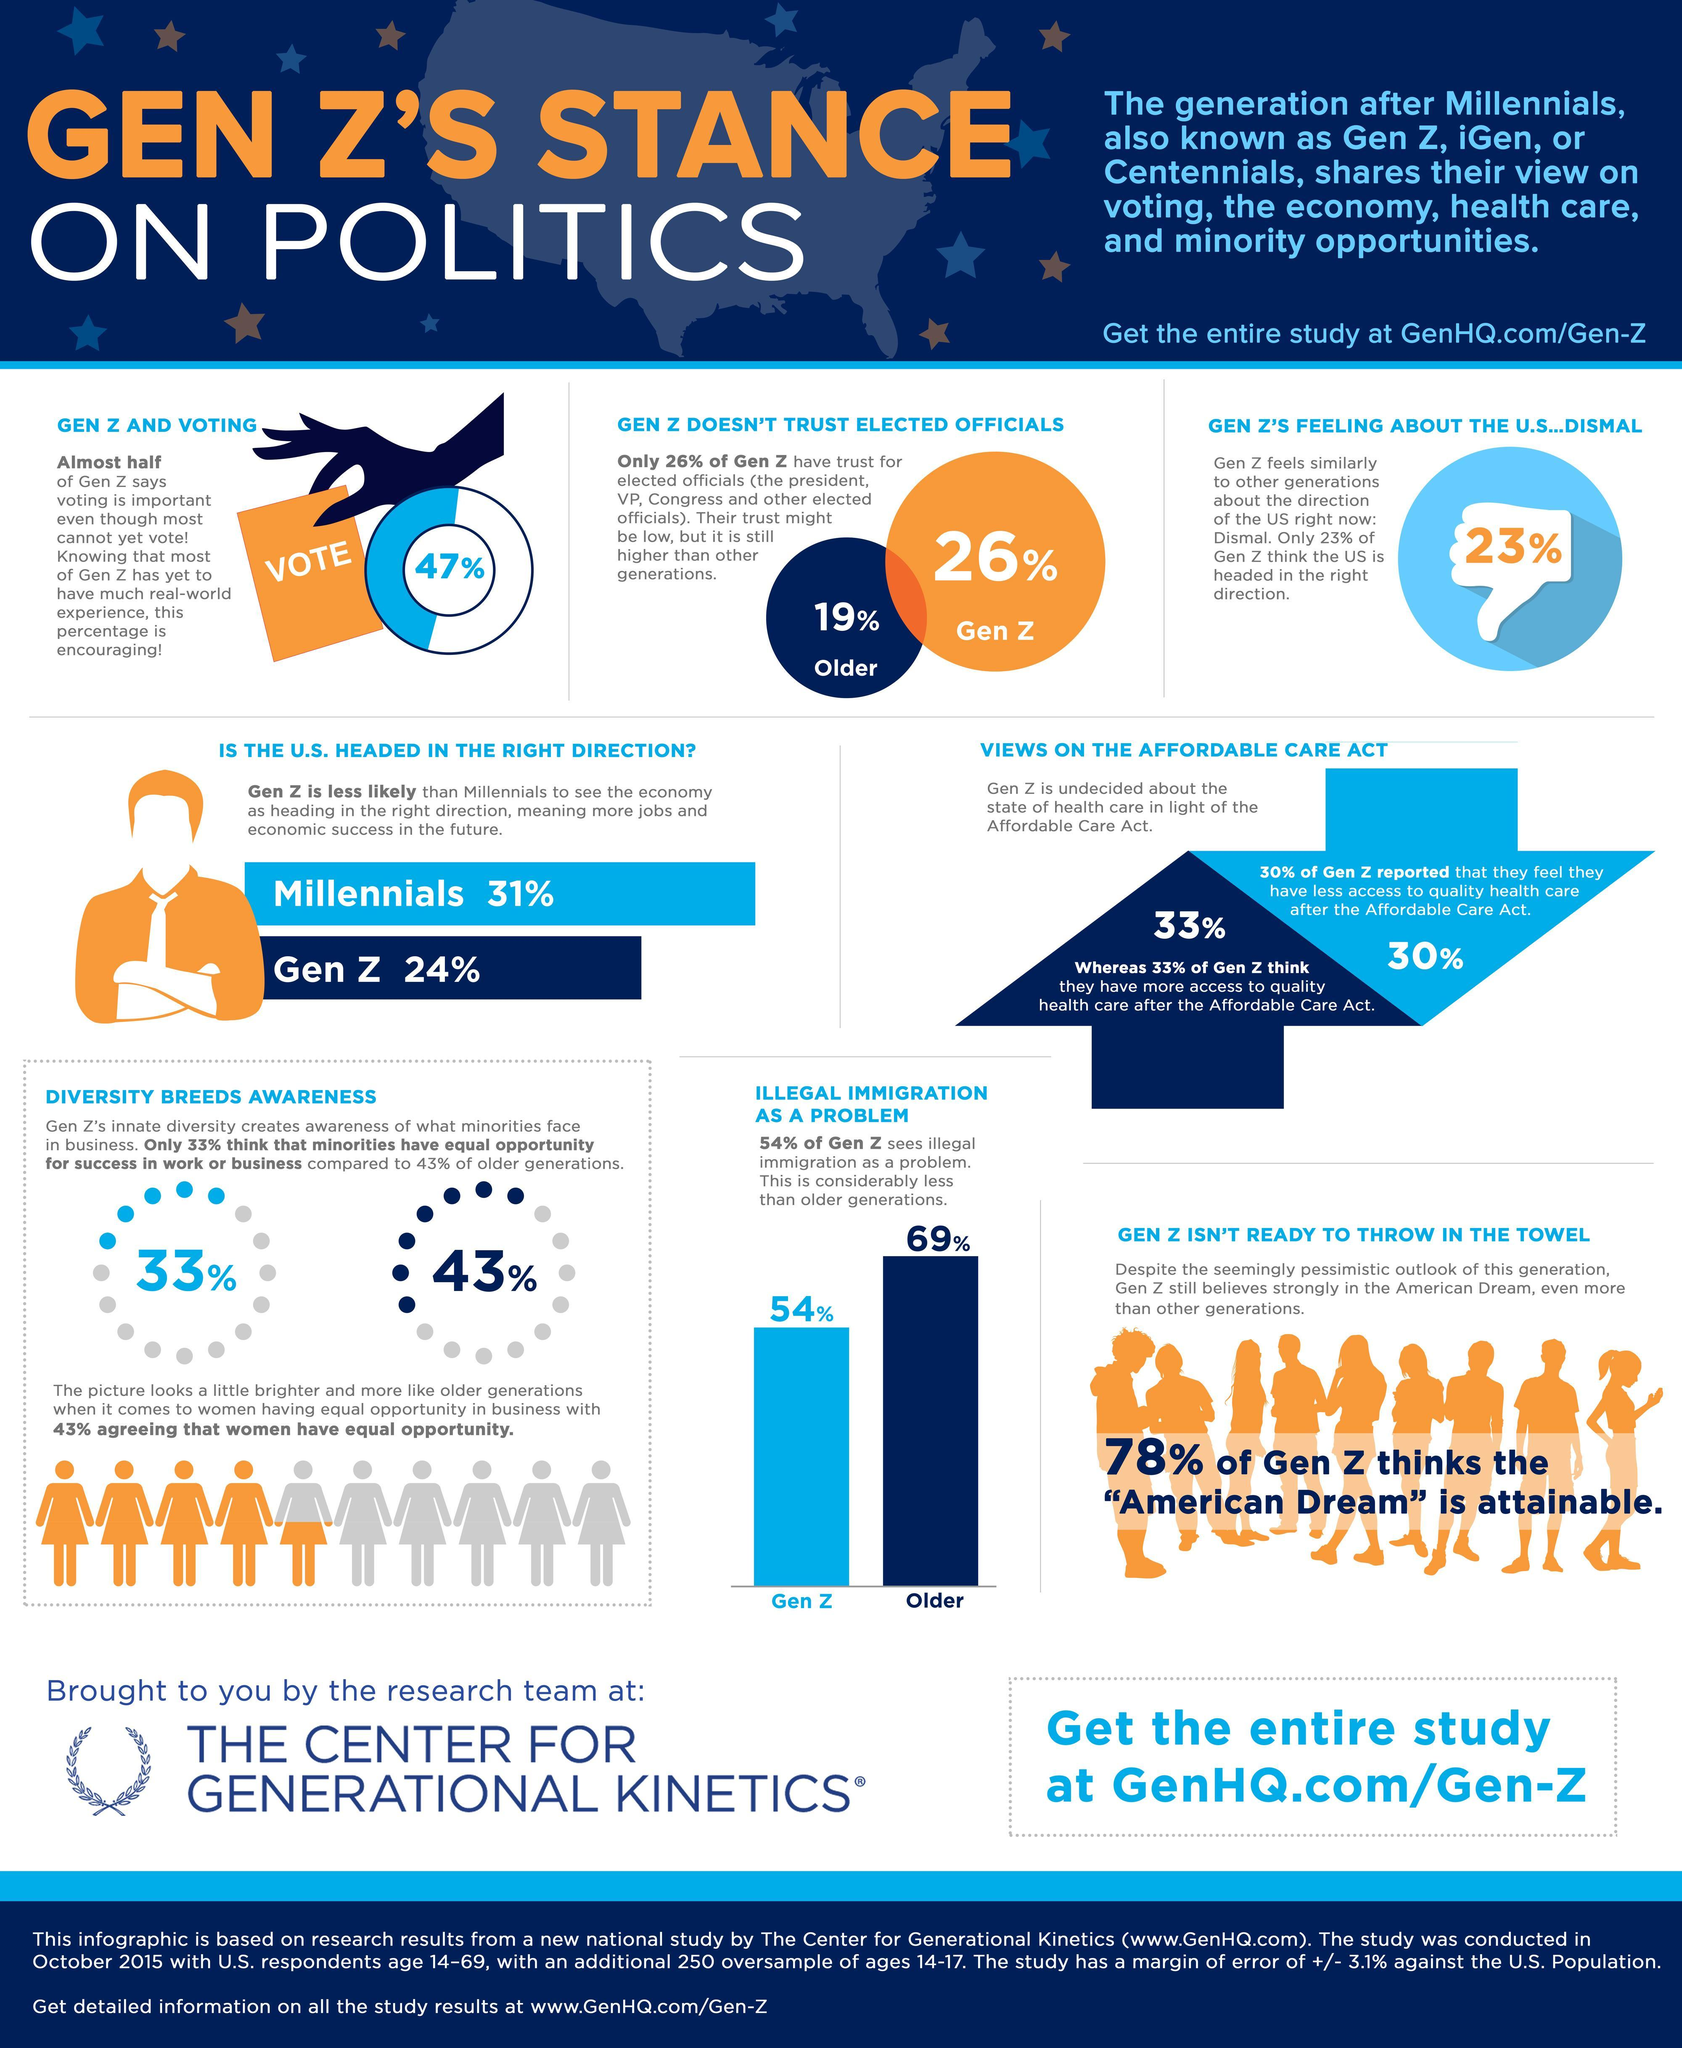what percent of older generation thinks that illegal immigration is a problem?
Answer the question with a short phrase. 69% what percent of older generation trust elected officials? 19 what percent of Gen Z thinks that economy is heading in the right direction? 24 what percent of older generation thinks that minorities have equal opportunity? 43% what percent of gen z does not agree that women have equal opportunity? 57% 